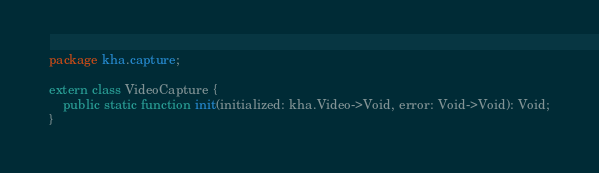<code> <loc_0><loc_0><loc_500><loc_500><_Haxe_>package kha.capture;

extern class VideoCapture {
	public static function init(initialized: kha.Video->Void, error: Void->Void): Void;
}
</code> 